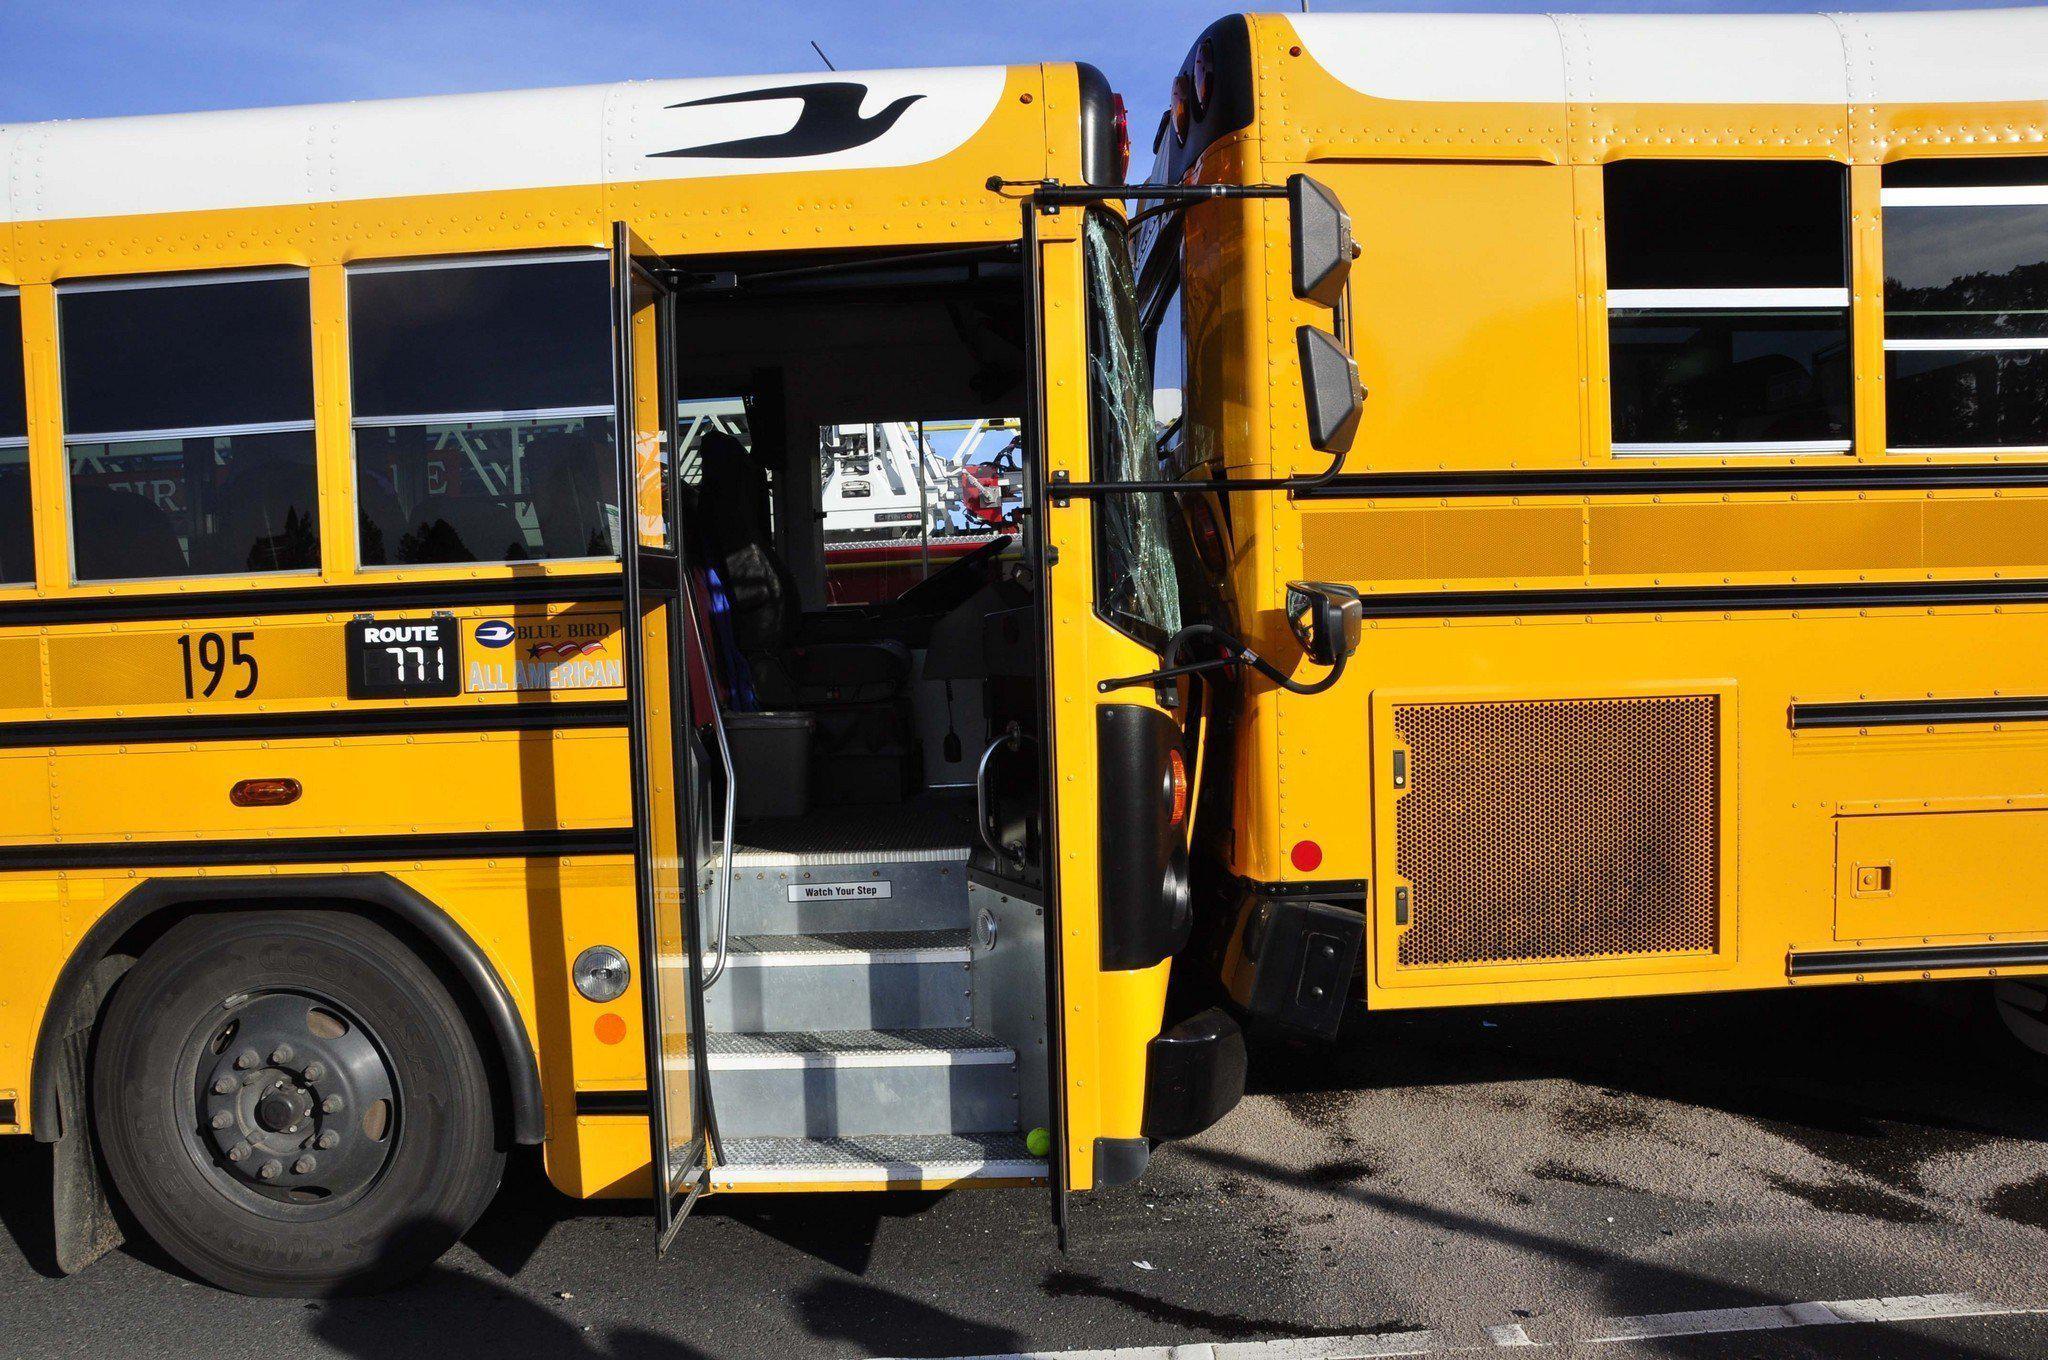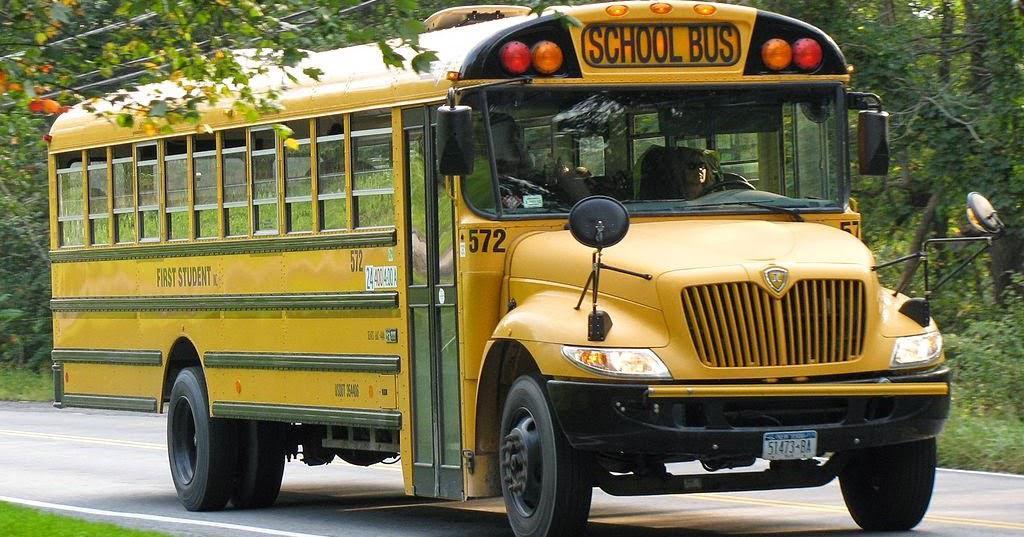The first image is the image on the left, the second image is the image on the right. Given the left and right images, does the statement "Each image shows a yellow school bus which has been damaged in an accident." hold true? Answer yes or no. No. The first image is the image on the left, the second image is the image on the right. Given the left and right images, does the statement "The school bus door is open and ready to accept passengers." hold true? Answer yes or no. Yes. 